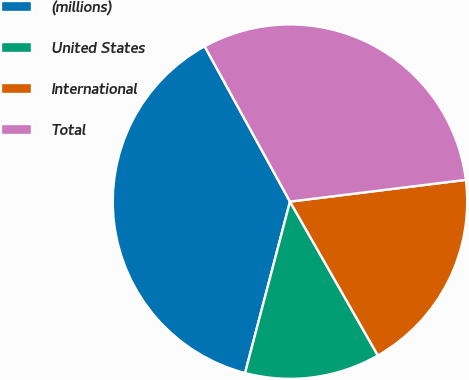Convert chart. <chart><loc_0><loc_0><loc_500><loc_500><pie_chart><fcel>(millions)<fcel>United States<fcel>International<fcel>Total<nl><fcel>37.92%<fcel>12.34%<fcel>18.7%<fcel>31.04%<nl></chart> 